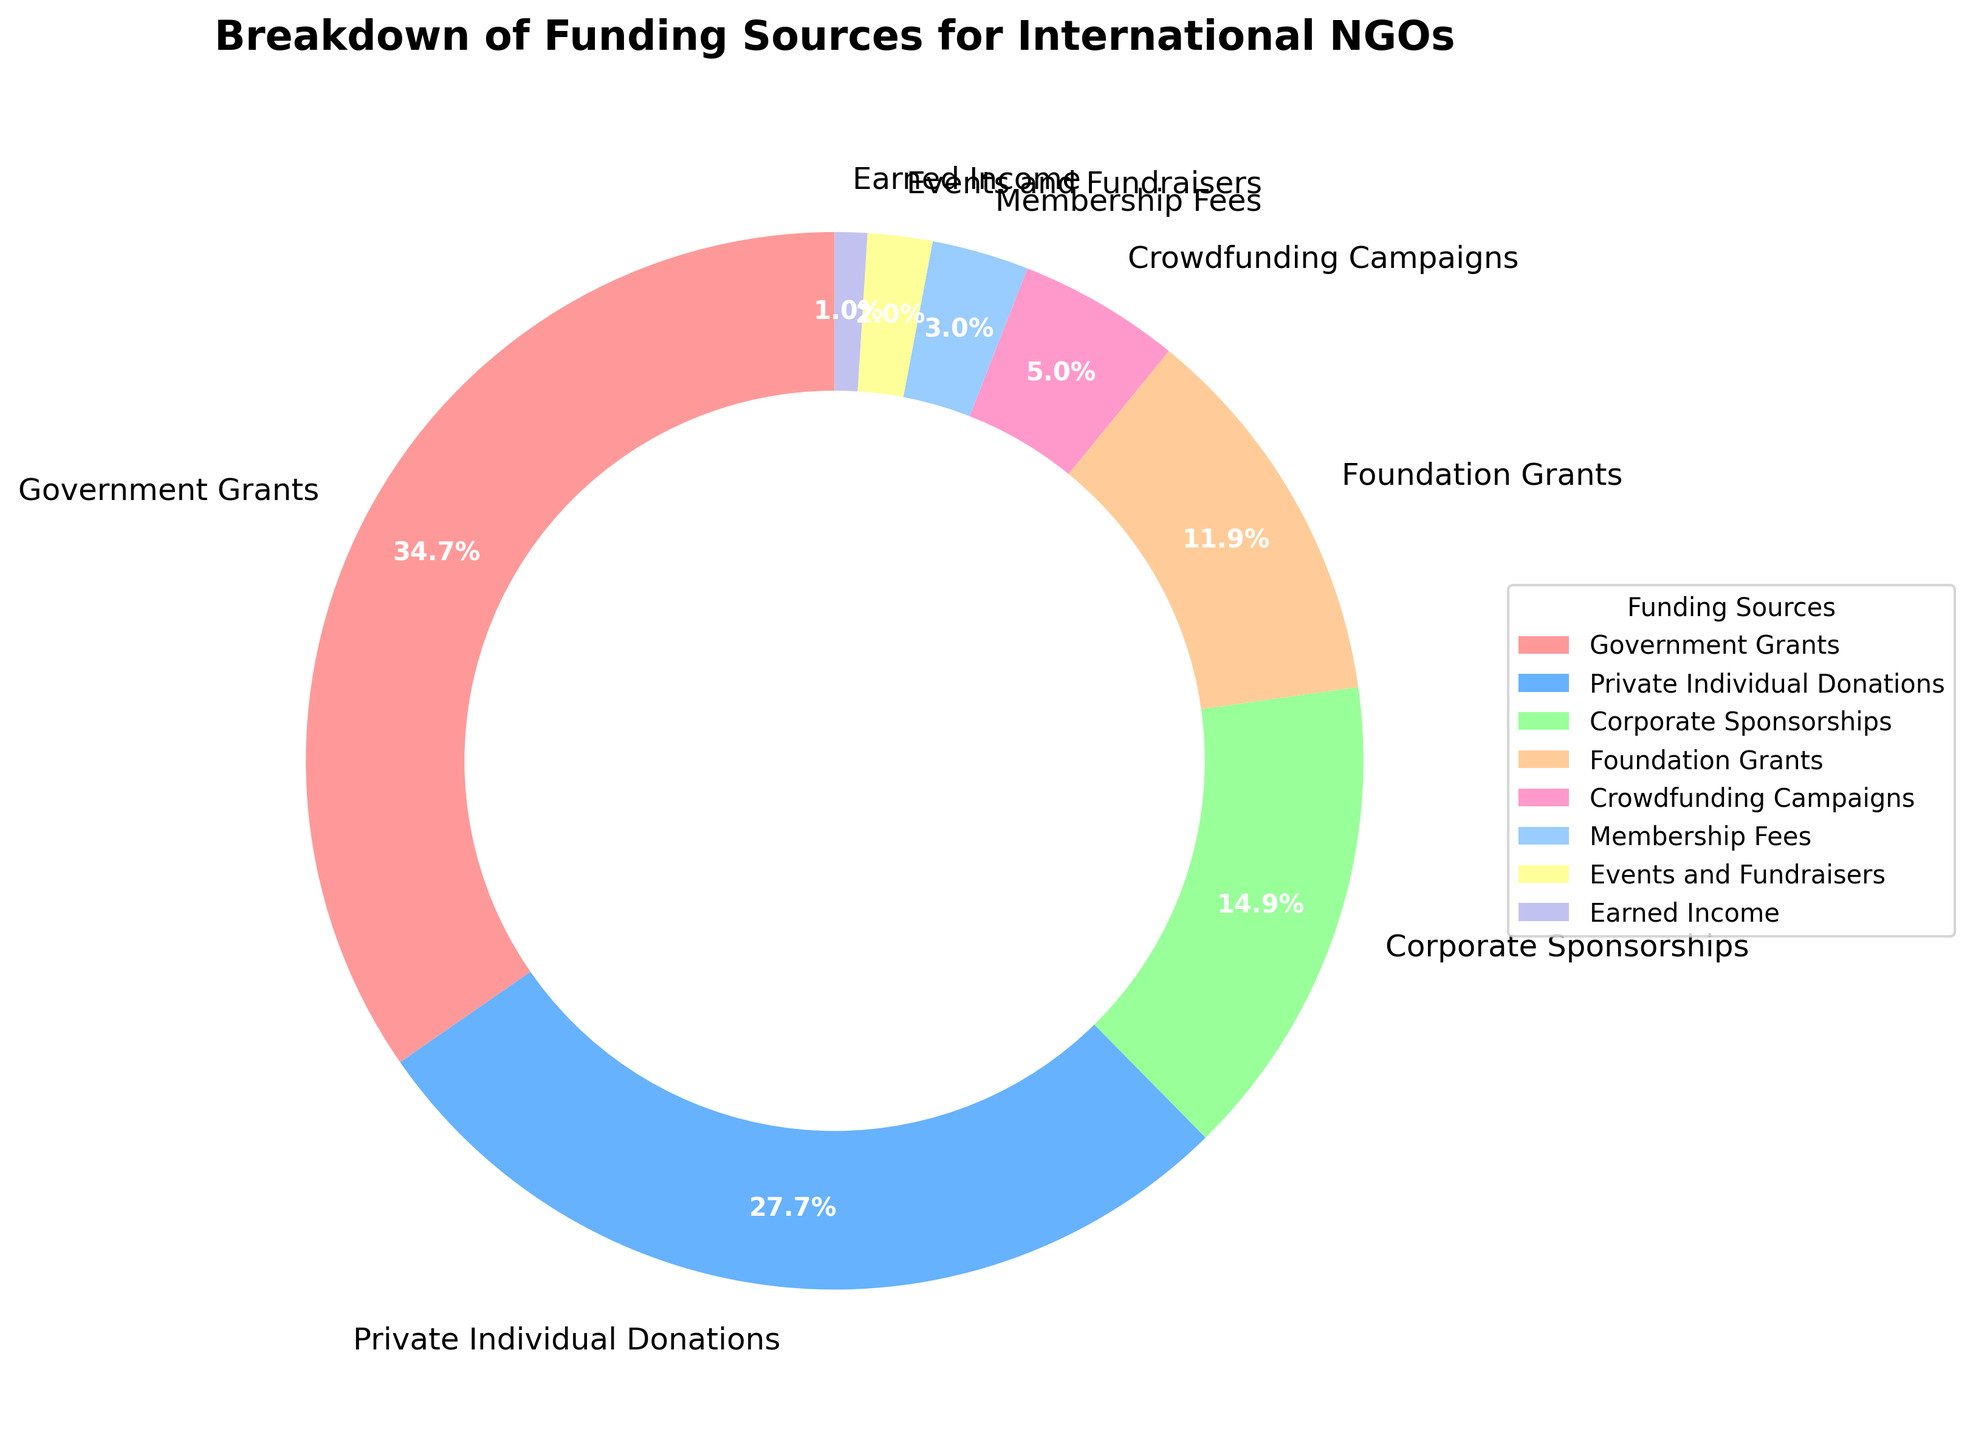Which funding source provides the highest percentage of funding? From the pie chart, "Government Grants" section occupies the largest segment and is labeled with 35%.
Answer: Government Grants Which two funding sources together contribute nearly half of the total funding? "Government Grants" at 35% and "Private Individual Donations" at 28% together equal 63%, which is more than half. So look for the next closest percentage which when added sums to 50%.
Answer: Government Grants and Private Individual Donations Which funding source contributes the least to the total funding? The smallest segment in the pie chart is labeled "Earned Income" with just 1%.
Answer: Earned Income Are the contributions from "Corporate Sponsorships" and "Foundation Grants" combined higher or lower than "Private Individual Donations"? "Corporate Sponsorships" have 15% and "Foundation Grants" have 12%. Adding these gives 27%, which is less than "Private Individual Donations" at 28%.
Answer: Lower Is the percentage contribution of "Private Individual Donations" more than twice that of "Crowdfunding Campaigns"? "Private Individual Donations" are 28%, and "Crowdfunding Campaigns" are 5%. Doubling 5% gives 10%, which is well below 28%.
Answer: Yes What is the difference between the highest and the second highest funding sources? The highest is "Government Grants" at 35% and the second highest is "Private Individual Donations" at 28%. Subtracting these gives 35 - 28 = 7%.
Answer: 7% Which category is indicated by the green segment in the pie chart, and what percentage does it represent? By identifying the green color segment visually, it corresponds to "Corporate Sponsorships," which is labeled at 15%.
Answer: Corporate Sponsorships at 15% Which combined sources make up exactly one-third of the total funding? One-third of 100% is about 33%. "Private Individual Donations" at 28% and "Crowdfunding Campaigns" at 5% together sum to 33%.
Answer: Private Individual Donations and Crowdfunding Campaigns What funding sources collectively surpass half of the total funding? Adding top segments: "Government Grants" (35%) and "Private Individual Donations" (28%) together give 63%, which exceeds half.
Answer: Government Grants and Private Individual Donations Among the sources "Foundation Grants", "Crowdfunding Campaigns", and "Membership Fees", which one contributes the highest percentage? "Foundation Grants" at 12%, "Crowdfunding Campaigns" at 5%, and "Membership Fees" at 3%—thus, "Foundation Grants" contribute the most.
Answer: Foundation Grants 